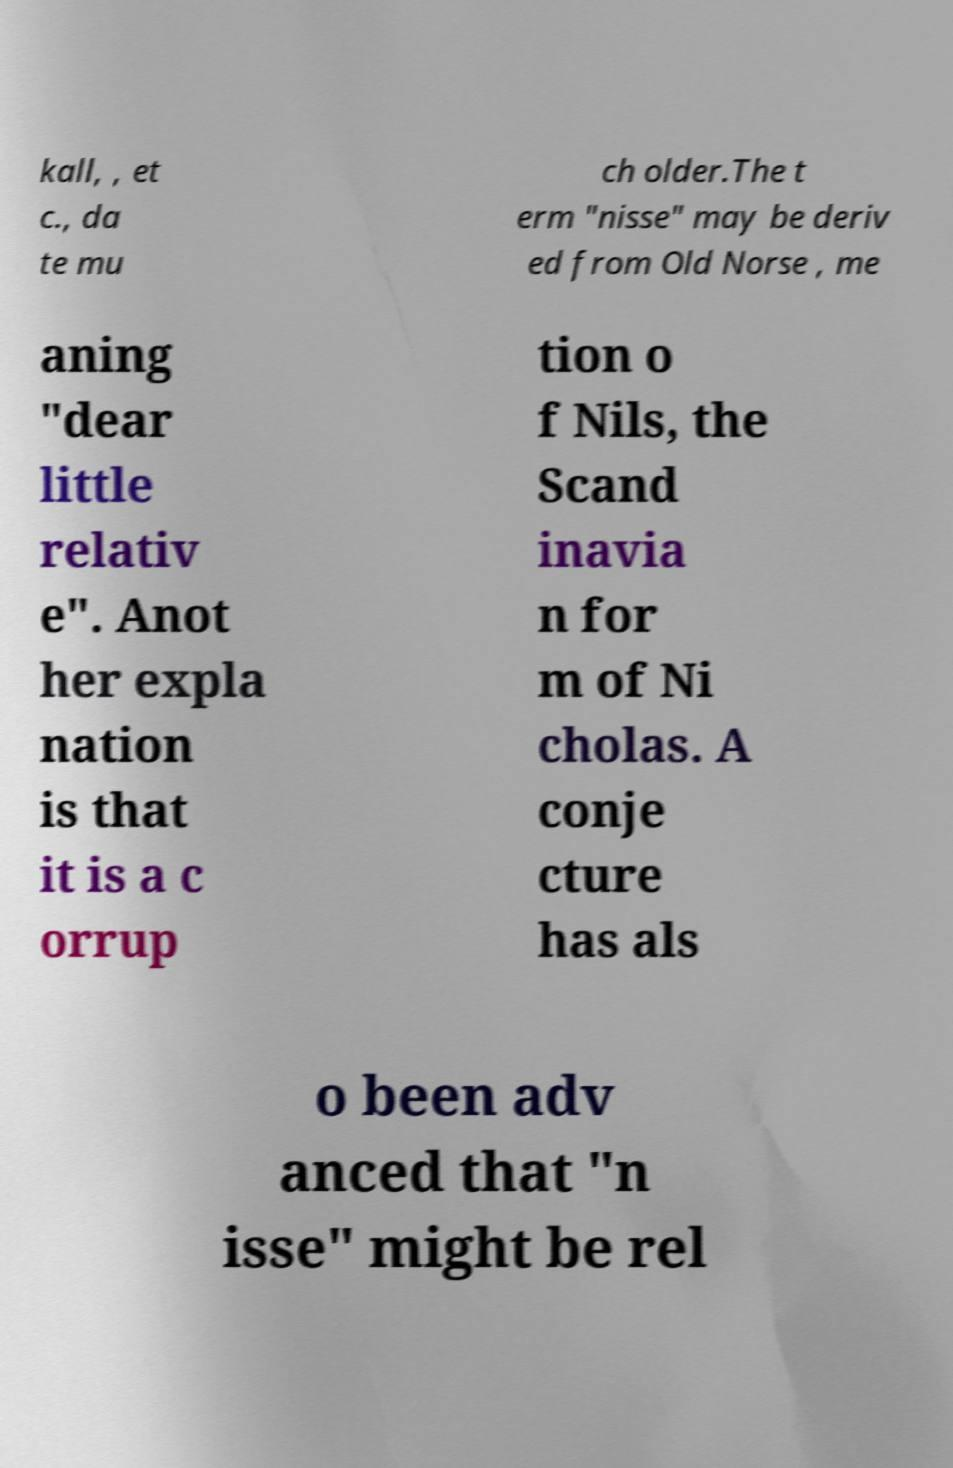I need the written content from this picture converted into text. Can you do that? kall, , et c., da te mu ch older.The t erm "nisse" may be deriv ed from Old Norse , me aning "dear little relativ e". Anot her expla nation is that it is a c orrup tion o f Nils, the Scand inavia n for m of Ni cholas. A conje cture has als o been adv anced that "n isse" might be rel 